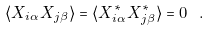<formula> <loc_0><loc_0><loc_500><loc_500>\langle X _ { i \alpha } X _ { j \beta } \rangle = \langle X ^ { * } _ { i \alpha } X ^ { * } _ { j \beta } \rangle = 0 \ .</formula> 